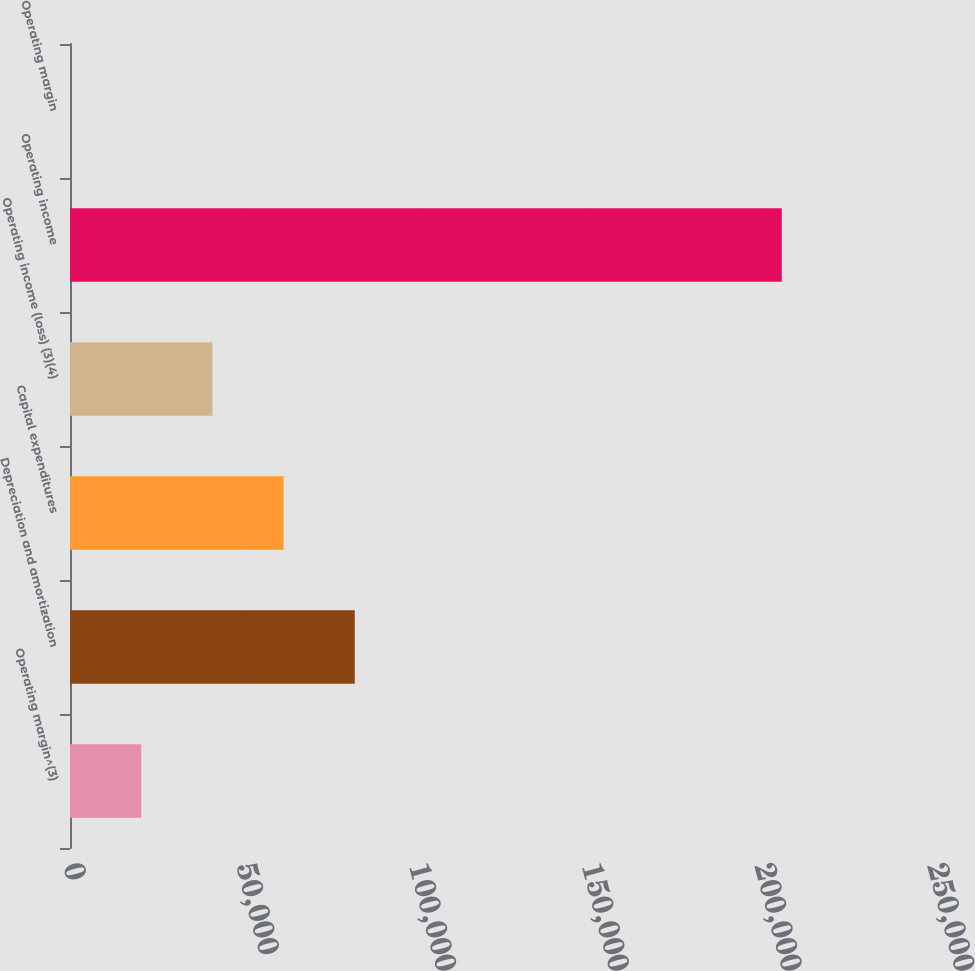<chart> <loc_0><loc_0><loc_500><loc_500><bar_chart><fcel>Operating margin^(3)<fcel>Depreciation and amortization<fcel>Capital expenditures<fcel>Operating income (loss) (3)(4)<fcel>Operating income<fcel>Operating margin<nl><fcel>20608<fcel>82390.7<fcel>61796.5<fcel>41202.2<fcel>205956<fcel>13.8<nl></chart> 